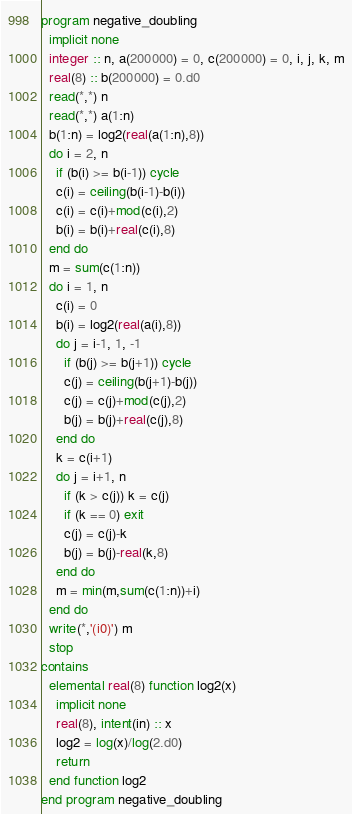Convert code to text. <code><loc_0><loc_0><loc_500><loc_500><_FORTRAN_>program negative_doubling
  implicit none
  integer :: n, a(200000) = 0, c(200000) = 0, i, j, k, m
  real(8) :: b(200000) = 0.d0
  read(*,*) n
  read(*,*) a(1:n)
  b(1:n) = log2(real(a(1:n),8))
  do i = 2, n
    if (b(i) >= b(i-1)) cycle
    c(i) = ceiling(b(i-1)-b(i))
    c(i) = c(i)+mod(c(i),2)
    b(i) = b(i)+real(c(i),8)
  end do
  m = sum(c(1:n))
  do i = 1, n
    c(i) = 0
    b(i) = log2(real(a(i),8))
    do j = i-1, 1, -1
      if (b(j) >= b(j+1)) cycle
      c(j) = ceiling(b(j+1)-b(j))
      c(j) = c(j)+mod(c(j),2)
      b(j) = b(j)+real(c(j),8)
    end do
    k = c(i+1)
    do j = i+1, n
      if (k > c(j)) k = c(j)
      if (k == 0) exit
      c(j) = c(j)-k
      b(j) = b(j)-real(k,8)
    end do
    m = min(m,sum(c(1:n))+i)
  end do
  write(*,'(i0)') m
  stop
contains
  elemental real(8) function log2(x)
    implicit none
    real(8), intent(in) :: x
    log2 = log(x)/log(2.d0)
    return
  end function log2
end program negative_doubling</code> 